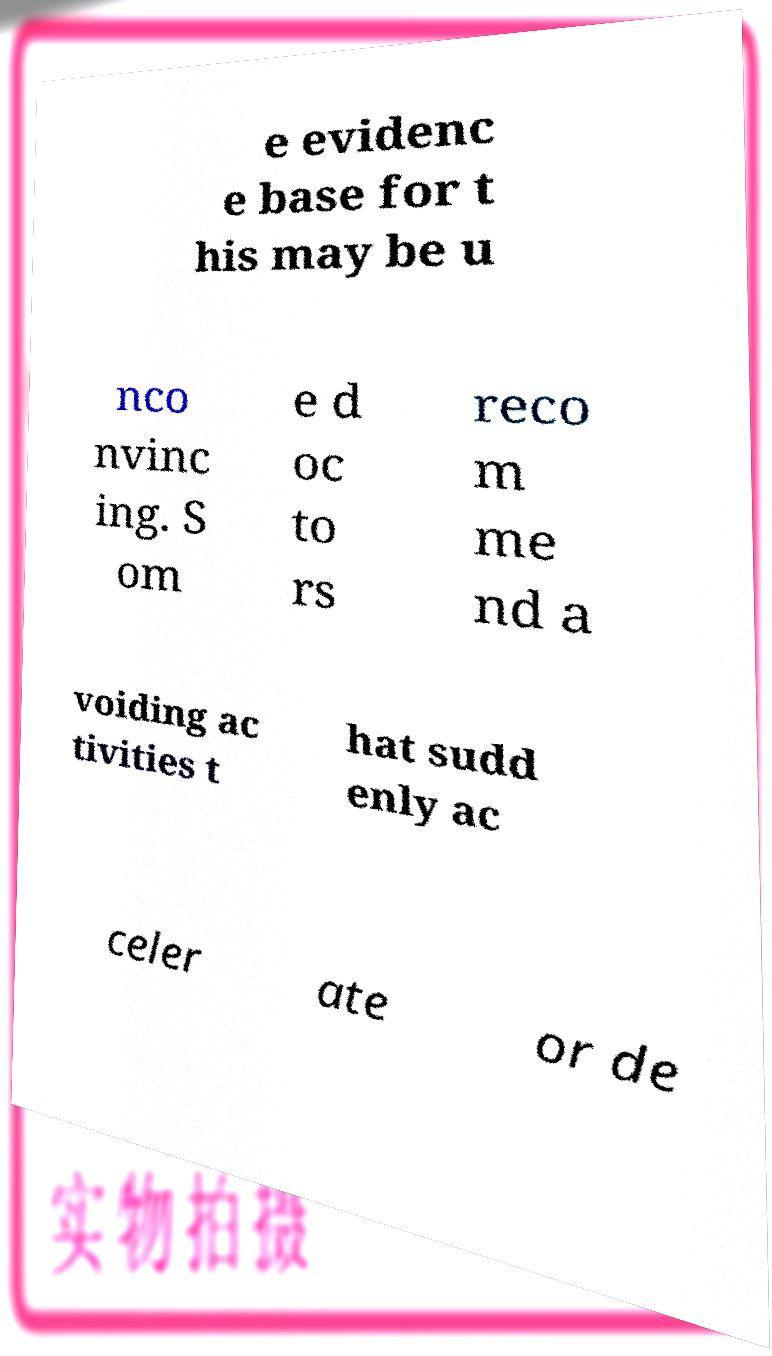Can you read and provide the text displayed in the image?This photo seems to have some interesting text. Can you extract and type it out for me? e evidenc e base for t his may be u nco nvinc ing. S om e d oc to rs reco m me nd a voiding ac tivities t hat sudd enly ac celer ate or de 